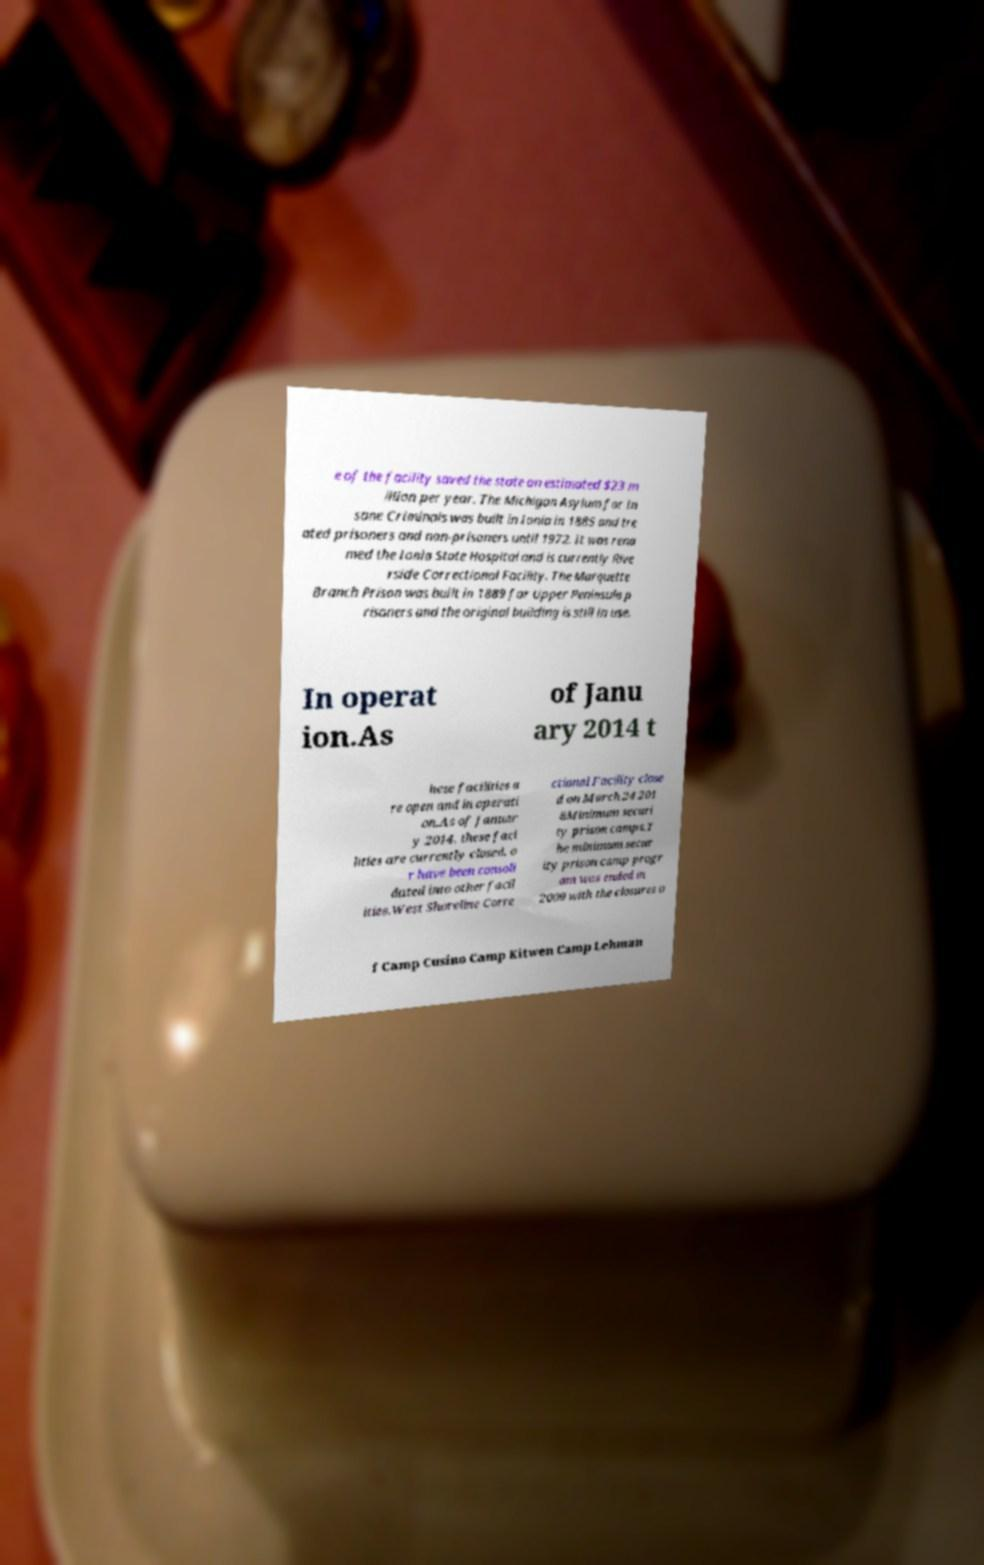Could you extract and type out the text from this image? e of the facility saved the state an estimated $23 m illion per year. The Michigan Asylum for In sane Criminals was built in Ionia in 1885 and tre ated prisoners and non-prisoners until 1972. It was rena med the Ionia State Hospital and is currently Rive rside Correctional Facility. The Marquette Branch Prison was built in 1889 for Upper Peninsula p risoners and the original building is still in use. In operat ion.As of Janu ary 2014 t hese facilities a re open and in operati on.As of Januar y 2014, these faci lities are currently closed, o r have been consoli dated into other facil ities.West Shoreline Corre ctional Facility close d on March 24 201 8Minimum securi ty prison camps.T he minimum secur ity prison camp progr am was ended in 2009 with the closures o f Camp Cusino Camp Kitwen Camp Lehman 